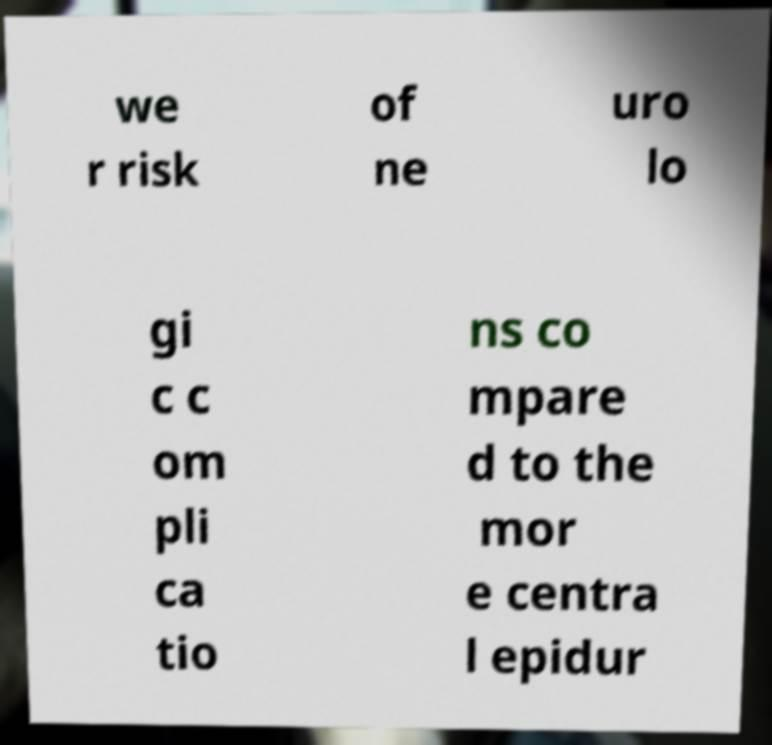Can you read and provide the text displayed in the image?This photo seems to have some interesting text. Can you extract and type it out for me? we r risk of ne uro lo gi c c om pli ca tio ns co mpare d to the mor e centra l epidur 